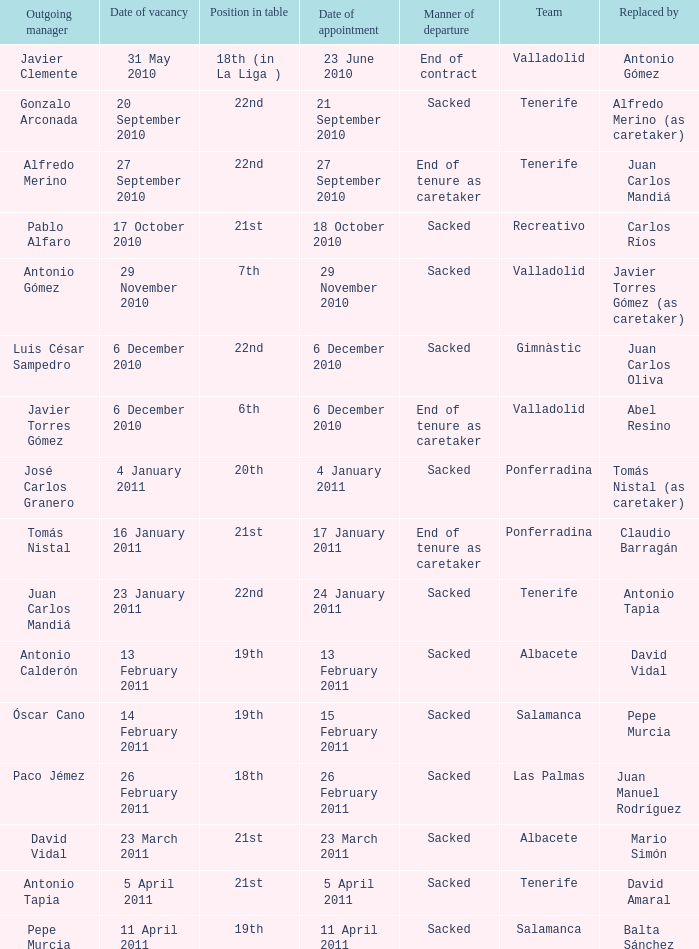Would you mind parsing the complete table? {'header': ['Outgoing manager', 'Date of vacancy', 'Position in table', 'Date of appointment', 'Manner of departure', 'Team', 'Replaced by'], 'rows': [['Javier Clemente', '31 May 2010', '18th (in La Liga )', '23 June 2010', 'End of contract', 'Valladolid', 'Antonio Gómez'], ['Gonzalo Arconada', '20 September 2010', '22nd', '21 September 2010', 'Sacked', 'Tenerife', 'Alfredo Merino (as caretaker)'], ['Alfredo Merino', '27 September 2010', '22nd', '27 September 2010', 'End of tenure as caretaker', 'Tenerife', 'Juan Carlos Mandiá'], ['Pablo Alfaro', '17 October 2010', '21st', '18 October 2010', 'Sacked', 'Recreativo', 'Carlos Ríos'], ['Antonio Gómez', '29 November 2010', '7th', '29 November 2010', 'Sacked', 'Valladolid', 'Javier Torres Gómez (as caretaker)'], ['Luis César Sampedro', '6 December 2010', '22nd', '6 December 2010', 'Sacked', 'Gimnàstic', 'Juan Carlos Oliva'], ['Javier Torres Gómez', '6 December 2010', '6th', '6 December 2010', 'End of tenure as caretaker', 'Valladolid', 'Abel Resino'], ['José Carlos Granero', '4 January 2011', '20th', '4 January 2011', 'Sacked', 'Ponferradina', 'Tomás Nistal (as caretaker)'], ['Tomás Nistal', '16 January 2011', '21st', '17 January 2011', 'End of tenure as caretaker', 'Ponferradina', 'Claudio Barragán'], ['Juan Carlos Mandiá', '23 January 2011', '22nd', '24 January 2011', 'Sacked', 'Tenerife', 'Antonio Tapia'], ['Antonio Calderón', '13 February 2011', '19th', '13 February 2011', 'Sacked', 'Albacete', 'David Vidal'], ['Óscar Cano', '14 February 2011', '19th', '15 February 2011', 'Sacked', 'Salamanca', 'Pepe Murcia'], ['Paco Jémez', '26 February 2011', '18th', '26 February 2011', 'Sacked', 'Las Palmas', 'Juan Manuel Rodríguez'], ['David Vidal', '23 March 2011', '21st', '23 March 2011', 'Sacked', 'Albacete', 'Mario Simón'], ['Antonio Tapia', '5 April 2011', '21st', '5 April 2011', 'Sacked', 'Tenerife', 'David Amaral'], ['Pepe Murcia', '11 April 2011', '19th', '11 April 2011', 'Sacked', 'Salamanca', 'Balta Sánchez']]} What was the position of appointment date 17 january 2011 21st. 